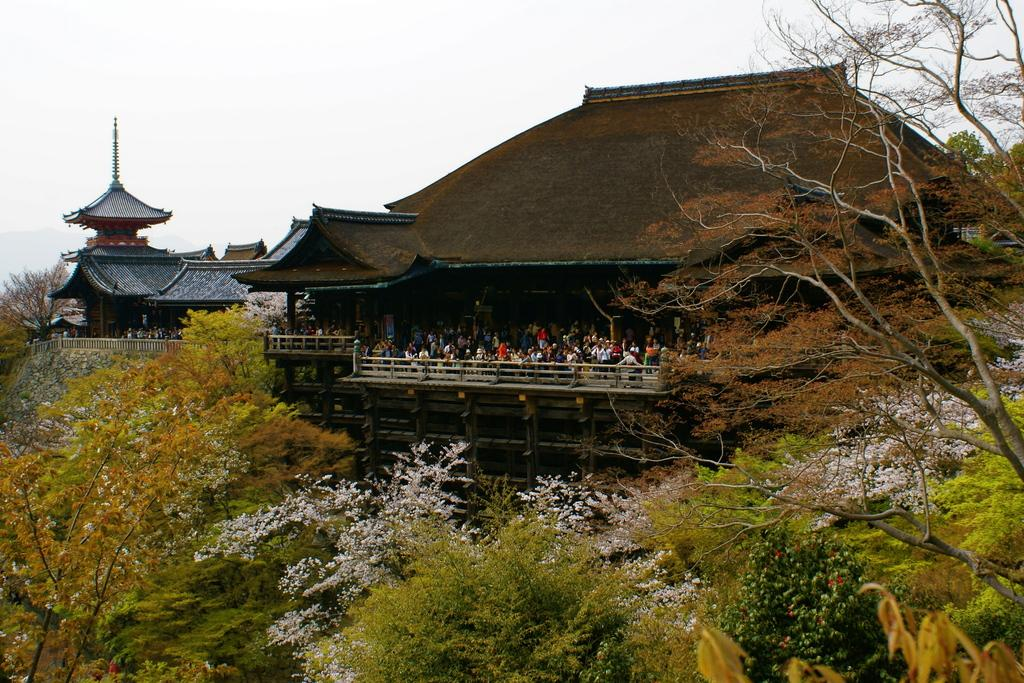What type of structures are present in the image? There are buildings in the image. Can you describe the activity taking place inside the buildings? There are people inside the buildings. What type of vegetation is present in front of the buildings? There are trees in front of the buildings. What can be seen in the background of the image? The sky is visible in the background of the image. What month is it in the image? The month cannot be determined from the image, as there is no information about the time of year or any seasonal indicators present. 